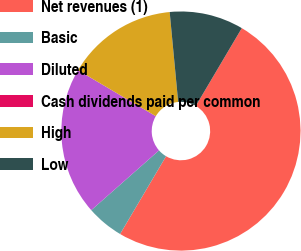Convert chart to OTSL. <chart><loc_0><loc_0><loc_500><loc_500><pie_chart><fcel>Net revenues (1)<fcel>Basic<fcel>Diluted<fcel>Cash dividends paid per common<fcel>High<fcel>Low<nl><fcel>49.99%<fcel>5.0%<fcel>20.0%<fcel>0.0%<fcel>15.0%<fcel>10.0%<nl></chart> 